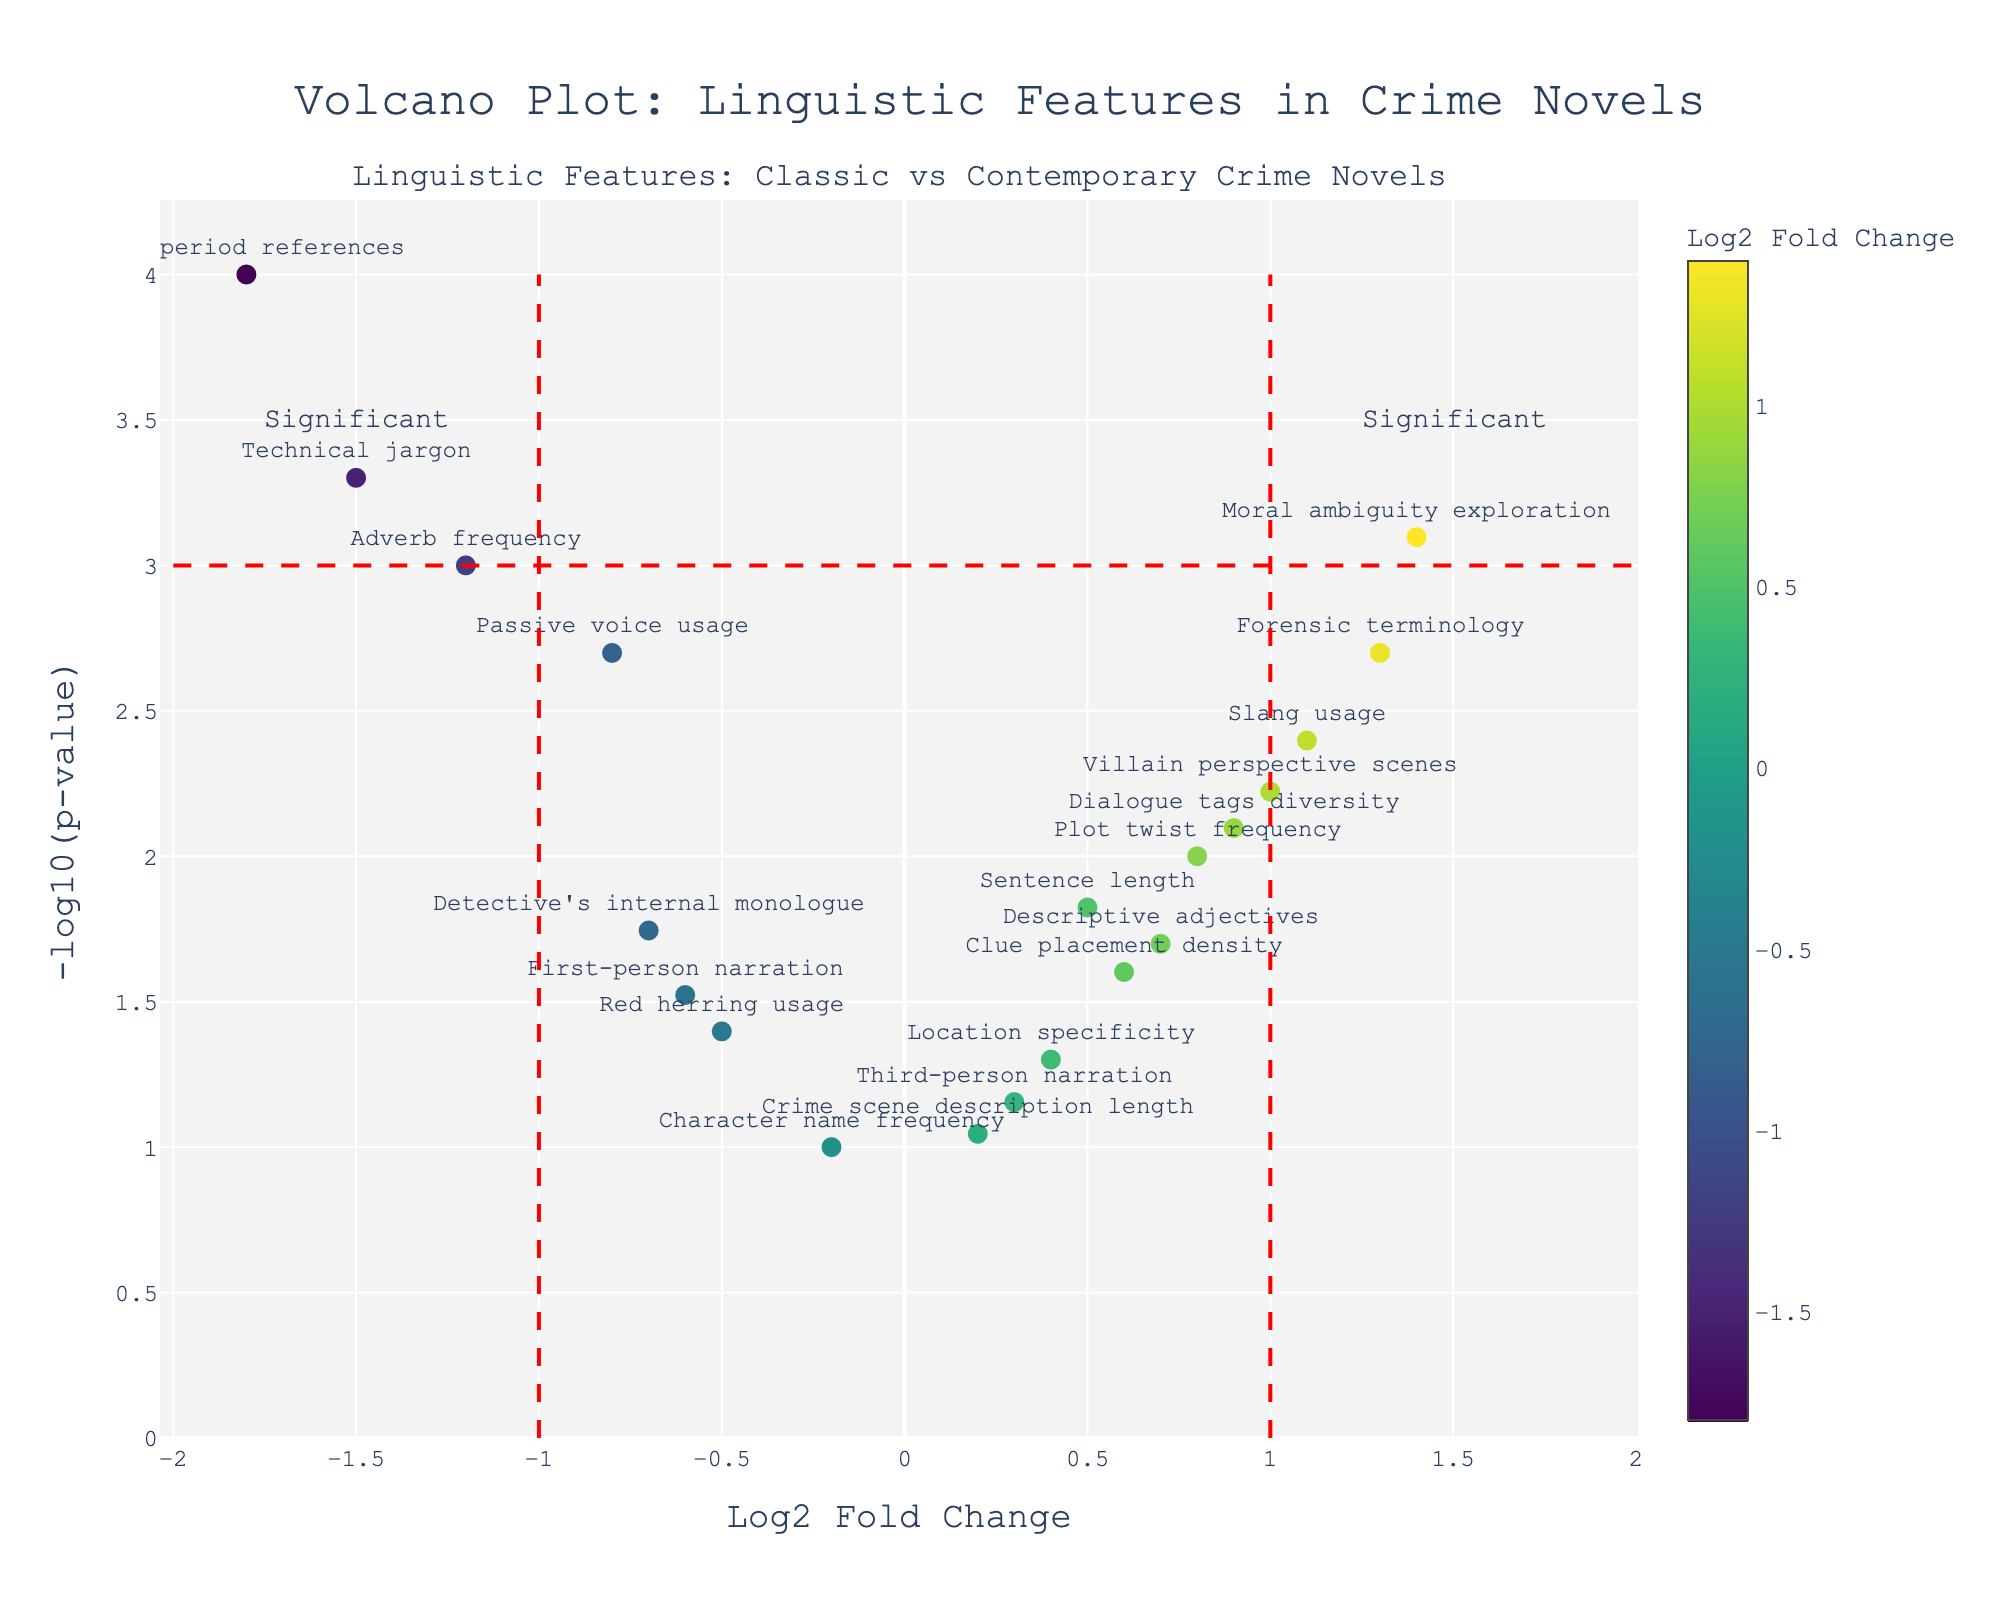What does the title of the plot tell us? The title of the plot is "Volcano Plot: Linguistic Features in Crime Novels." This indicates that the plot compares various linguistic features in classic versus contemporary crime novels.
Answer: Volcano Plot: Linguistic Features in Crime Novels What are the axes titles in the plot? The x-axis title is "Log2 Fold Change," and the y-axis title is "-log10(p-value)." This means the x-axis represents the log2 fold change of linguistic features, while the y-axis represents the negative logarithm (base 10) of the p-value.
Answer: Log2 Fold Change and -log10(p-value) How many features have a log2 fold change greater than 1? From the scatter plot, we can observe which data points fall to the right of the vertical line at x = 1.
Answer: Five features Which feature has the smallest p-value? The feature with the highest -log10(p-value) value will have the smallest p-value.
Answer: Time period references Which feature shows the highest log2 fold change? The feature with the farthest positive deviation along the x-axis (log2 fold change) in the positive direction indicates the highest log2 fold change.
Answer: Moral ambiguity exploration Which features are considered significant according to the provided significance lines? Features that lie beyond the vertical red dashed lines at -1 and 1, with a -log10(p-value) greater than 3, are considered significant. We identify these features by their position relative to these lines.
Answer: Adverb frequency, Technical jargon, Time period references, Moral ambiguity exploration Are there any features with log2 fold change almost equal to 0? If yes, which ones? Features with log2 fold change around 0 will be positioned close to the central vertical axis at x = 0.
Answer: Third-person narration, Character name frequency, Crime scene description length How does the frequency of forensic terminology compare to technical jargon? By comparing their positions on the plot along the x-axis and y-axis, we can interpret that forensic terminology (positive fold change) is more frequent in contemporary works, while technical jargon (negative fold change) is less frequent.
Answer: Forensic terminology is more frequent in contemporary works than technical jargon Out of all significant features, which one has the highest p-value? Among the features identified as significant, locate the one with the lowest -log10(p-value) value.
Answer: Moral ambiguity exploration Which features use more adverbs in classic novels compared to contemporary novels? Features with negative log2 fold change values represent higher usage in classic novels. Locate the feature for adverb frequency.
Answer: Adverb frequency 